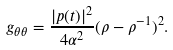<formula> <loc_0><loc_0><loc_500><loc_500>g _ { \theta \theta } = \frac { | p ( t ) | ^ { 2 } } { 4 \alpha ^ { 2 } } ( \rho - \rho ^ { - 1 } ) ^ { 2 } .</formula> 